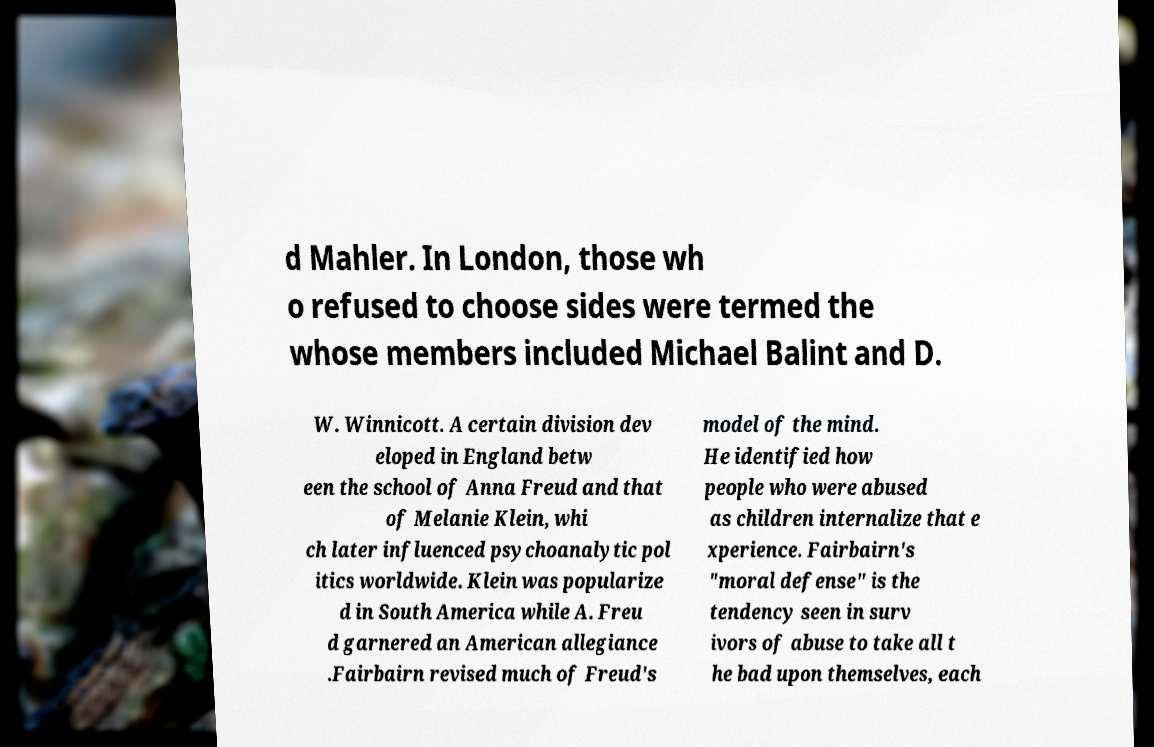Please read and relay the text visible in this image. What does it say? d Mahler. In London, those wh o refused to choose sides were termed the whose members included Michael Balint and D. W. Winnicott. A certain division dev eloped in England betw een the school of Anna Freud and that of Melanie Klein, whi ch later influenced psychoanalytic pol itics worldwide. Klein was popularize d in South America while A. Freu d garnered an American allegiance .Fairbairn revised much of Freud's model of the mind. He identified how people who were abused as children internalize that e xperience. Fairbairn's "moral defense" is the tendency seen in surv ivors of abuse to take all t he bad upon themselves, each 